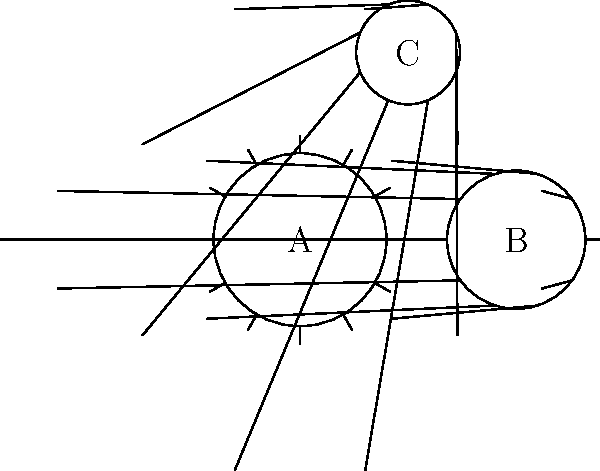In the gear arrangement shown, gears A, B, and C have 12, 10, and 8 teeth respectively. If gear A completes one full rotation clockwise, how many rotations will gear C complete, and in which direction? To solve this problem, we'll follow these steps:

1) First, we need to understand how the rotations are transferred between gears:
   - When two gears mesh, they rotate in opposite directions.
   - The number of rotations is inversely proportional to the number of teeth.

2) Let's start with the rotation from gear A to gear B:
   - A has 12 teeth and B has 10 teeth.
   - For one full rotation of A, B will rotate: $\frac{12}{10} = 1.2$ rotations.
   - B will rotate counterclockwise (opposite to A's clockwise rotation).

3) Now, let's consider the rotation from gear B to gear C:
   - B has 10 teeth and C has 8 teeth.
   - For one full rotation of B, C will rotate: $\frac{10}{8} = 1.25$ rotations.
   - C will rotate clockwise (opposite to B's counterclockwise rotation).

4) To find C's total rotation:
   - We multiply the rotations: $1.2 \times 1.25 = 1.5$

Therefore, when gear A completes one full rotation clockwise, gear C will complete 1.5 rotations clockwise.
Answer: 1.5 rotations clockwise 